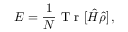Convert formula to latex. <formula><loc_0><loc_0><loc_500><loc_500>E = \frac { 1 } { N } T r [ \hat { H } \hat { \rho } ] \, ,</formula> 